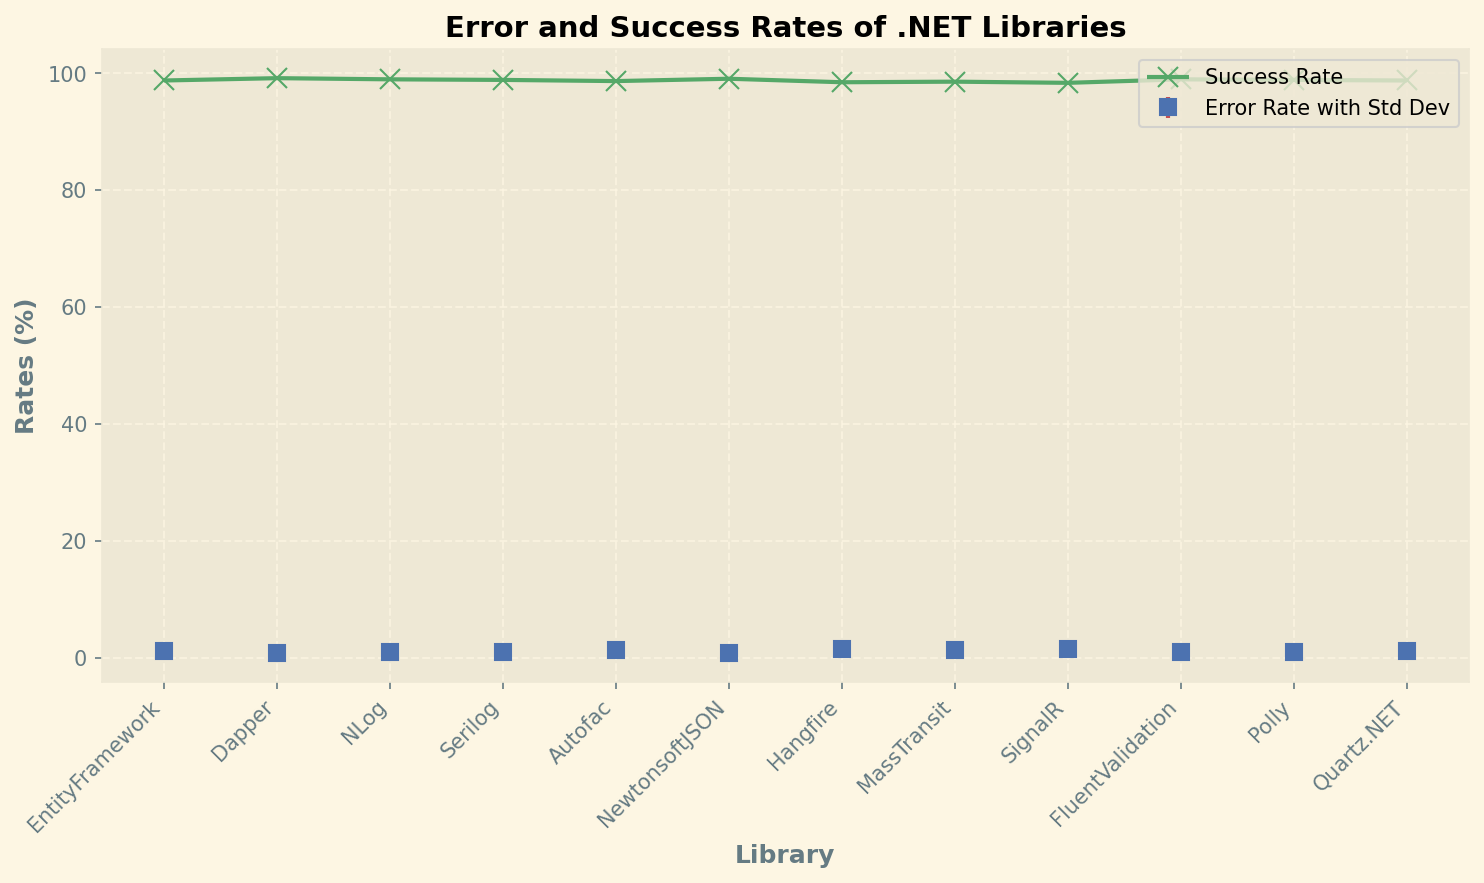Which .NET library has the lowest error rate with its standard deviation? Look at the blue markers (squares) with error bars on the plot. The library with the lowest error rate is Dapper, which also has a relatively small standard deviation.
Answer: Dapper Which library has the highest success rate? Observe the green 'x' markers on the plot. The library with the highest success rate is Dapper, which has a success rate of 99.2%.
Answer: Dapper Compare the error rates of EntityFramework and Quartz.NET. Which one is greater, and by how much? EntityFramework has an error rate of 1.2%, and Quartz.NET also has an error rate of 1.2%. So, the error rates are equal.
Answer: They are equal What is the average success rate of the libraries shown on the plot? Sum all the success rates: 98.8 + 99.2 + 99.0 + 98.9 + 98.7 + 99.1 + 98.5 + 98.6 + 98.4 + 99.0 + 98.9 + 98.8. The sum is 1185.7. There are 12 libraries, so divide the sum by 12. The average success rate is 1185.7/12 = 98.808%.
Answer: 98.808% By how much does the error rate of Hangfire exceed that of NLog? Subtract the error rate of NLog (1.0%) from the error rate of Hangfire (1.5%). The difference is 1.5% - 1.0% = 0.5%.
Answer: 0.5% Considering the standard deviations, which library has the most variability in its error rate? The library with the highest error rate standard deviation will have the most variability. SignalR shows the largest standard deviation in the error rate among the libraries, which is 0.08%.
Answer: SignalR Is there any library where the difference between the success rate and error rate is exactly 97.9%? Calculate the difference between the success rate and error rate for each library, looking for one where the difference is 97.9%. For Dapper, the difference is 99.2% - 0.8% = 98.4%. By continuing this for each library, we find that none of the libraries have exactly 97.9%.
Answer: No What is the total sum of the error rates for all the libraries? Sum up all the error rates: 1.2 + 0.8 + 1.0 + 1.1 + 1.3 + 0.9 + 1.5 + 1.4 + 1.6 + 1.0 + 1.1 + 1.2 = 14.1%.
Answer: 14.1% How does the success rate of Serilog compare to that of Polly? Compare the green 'x' markers for Serilog and Polly. Both have a success rate of 98.9%. Therefore, their success rates are equal.
Answer: They are equal 